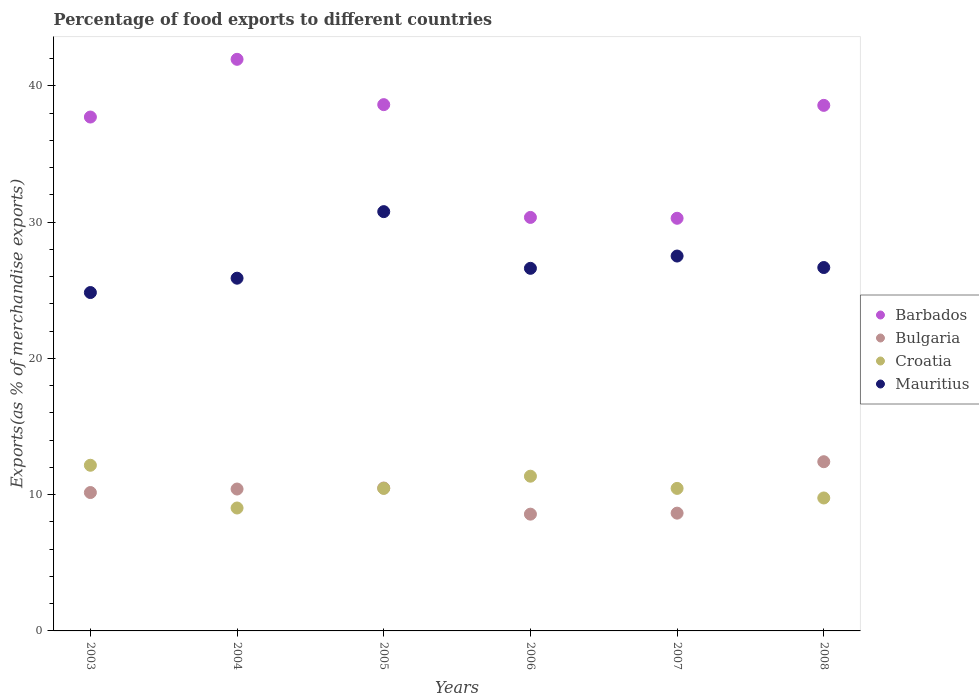How many different coloured dotlines are there?
Give a very brief answer. 4. Is the number of dotlines equal to the number of legend labels?
Provide a short and direct response. Yes. What is the percentage of exports to different countries in Croatia in 2007?
Give a very brief answer. 10.46. Across all years, what is the maximum percentage of exports to different countries in Croatia?
Offer a terse response. 12.16. Across all years, what is the minimum percentage of exports to different countries in Croatia?
Your answer should be compact. 9.02. What is the total percentage of exports to different countries in Mauritius in the graph?
Make the answer very short. 162.29. What is the difference between the percentage of exports to different countries in Mauritius in 2006 and that in 2007?
Provide a short and direct response. -0.9. What is the difference between the percentage of exports to different countries in Croatia in 2004 and the percentage of exports to different countries in Bulgaria in 2003?
Your response must be concise. -1.13. What is the average percentage of exports to different countries in Mauritius per year?
Keep it short and to the point. 27.05. In the year 2005, what is the difference between the percentage of exports to different countries in Mauritius and percentage of exports to different countries in Barbados?
Provide a short and direct response. -7.85. In how many years, is the percentage of exports to different countries in Croatia greater than 14 %?
Provide a short and direct response. 0. What is the ratio of the percentage of exports to different countries in Bulgaria in 2004 to that in 2007?
Keep it short and to the point. 1.2. Is the difference between the percentage of exports to different countries in Mauritius in 2003 and 2005 greater than the difference between the percentage of exports to different countries in Barbados in 2003 and 2005?
Provide a succinct answer. No. What is the difference between the highest and the second highest percentage of exports to different countries in Barbados?
Provide a succinct answer. 3.33. What is the difference between the highest and the lowest percentage of exports to different countries in Croatia?
Provide a succinct answer. 3.14. Is it the case that in every year, the sum of the percentage of exports to different countries in Barbados and percentage of exports to different countries in Croatia  is greater than the sum of percentage of exports to different countries in Bulgaria and percentage of exports to different countries in Mauritius?
Give a very brief answer. No. Is it the case that in every year, the sum of the percentage of exports to different countries in Croatia and percentage of exports to different countries in Mauritius  is greater than the percentage of exports to different countries in Bulgaria?
Your response must be concise. Yes. How many dotlines are there?
Your answer should be compact. 4. What is the difference between two consecutive major ticks on the Y-axis?
Ensure brevity in your answer.  10. Does the graph contain any zero values?
Ensure brevity in your answer.  No. Does the graph contain grids?
Keep it short and to the point. No. Where does the legend appear in the graph?
Your response must be concise. Center right. How are the legend labels stacked?
Ensure brevity in your answer.  Vertical. What is the title of the graph?
Make the answer very short. Percentage of food exports to different countries. Does "Albania" appear as one of the legend labels in the graph?
Offer a very short reply. No. What is the label or title of the Y-axis?
Give a very brief answer. Exports(as % of merchandise exports). What is the Exports(as % of merchandise exports) of Barbados in 2003?
Offer a very short reply. 37.71. What is the Exports(as % of merchandise exports) of Bulgaria in 2003?
Give a very brief answer. 10.16. What is the Exports(as % of merchandise exports) of Croatia in 2003?
Provide a short and direct response. 12.16. What is the Exports(as % of merchandise exports) in Mauritius in 2003?
Your answer should be very brief. 24.83. What is the Exports(as % of merchandise exports) of Barbados in 2004?
Make the answer very short. 41.95. What is the Exports(as % of merchandise exports) of Bulgaria in 2004?
Offer a terse response. 10.41. What is the Exports(as % of merchandise exports) of Croatia in 2004?
Your response must be concise. 9.02. What is the Exports(as % of merchandise exports) in Mauritius in 2004?
Provide a succinct answer. 25.89. What is the Exports(as % of merchandise exports) of Barbados in 2005?
Your answer should be very brief. 38.62. What is the Exports(as % of merchandise exports) in Bulgaria in 2005?
Offer a very short reply. 10.49. What is the Exports(as % of merchandise exports) in Croatia in 2005?
Provide a succinct answer. 10.46. What is the Exports(as % of merchandise exports) of Mauritius in 2005?
Your answer should be compact. 30.77. What is the Exports(as % of merchandise exports) in Barbados in 2006?
Your answer should be very brief. 30.35. What is the Exports(as % of merchandise exports) of Bulgaria in 2006?
Provide a short and direct response. 8.57. What is the Exports(as % of merchandise exports) in Croatia in 2006?
Provide a succinct answer. 11.36. What is the Exports(as % of merchandise exports) of Mauritius in 2006?
Keep it short and to the point. 26.61. What is the Exports(as % of merchandise exports) in Barbados in 2007?
Give a very brief answer. 30.28. What is the Exports(as % of merchandise exports) of Bulgaria in 2007?
Your answer should be compact. 8.64. What is the Exports(as % of merchandise exports) in Croatia in 2007?
Keep it short and to the point. 10.46. What is the Exports(as % of merchandise exports) in Mauritius in 2007?
Provide a succinct answer. 27.51. What is the Exports(as % of merchandise exports) of Barbados in 2008?
Offer a very short reply. 38.57. What is the Exports(as % of merchandise exports) of Bulgaria in 2008?
Ensure brevity in your answer.  12.42. What is the Exports(as % of merchandise exports) in Croatia in 2008?
Give a very brief answer. 9.76. What is the Exports(as % of merchandise exports) in Mauritius in 2008?
Offer a terse response. 26.67. Across all years, what is the maximum Exports(as % of merchandise exports) of Barbados?
Give a very brief answer. 41.95. Across all years, what is the maximum Exports(as % of merchandise exports) in Bulgaria?
Your answer should be compact. 12.42. Across all years, what is the maximum Exports(as % of merchandise exports) in Croatia?
Offer a very short reply. 12.16. Across all years, what is the maximum Exports(as % of merchandise exports) in Mauritius?
Ensure brevity in your answer.  30.77. Across all years, what is the minimum Exports(as % of merchandise exports) of Barbados?
Ensure brevity in your answer.  30.28. Across all years, what is the minimum Exports(as % of merchandise exports) of Bulgaria?
Provide a succinct answer. 8.57. Across all years, what is the minimum Exports(as % of merchandise exports) in Croatia?
Offer a terse response. 9.02. Across all years, what is the minimum Exports(as % of merchandise exports) in Mauritius?
Keep it short and to the point. 24.83. What is the total Exports(as % of merchandise exports) of Barbados in the graph?
Offer a terse response. 217.49. What is the total Exports(as % of merchandise exports) of Bulgaria in the graph?
Your answer should be very brief. 60.69. What is the total Exports(as % of merchandise exports) of Croatia in the graph?
Your answer should be very brief. 63.21. What is the total Exports(as % of merchandise exports) of Mauritius in the graph?
Give a very brief answer. 162.29. What is the difference between the Exports(as % of merchandise exports) of Barbados in 2003 and that in 2004?
Offer a terse response. -4.24. What is the difference between the Exports(as % of merchandise exports) of Bulgaria in 2003 and that in 2004?
Your answer should be compact. -0.26. What is the difference between the Exports(as % of merchandise exports) of Croatia in 2003 and that in 2004?
Your response must be concise. 3.14. What is the difference between the Exports(as % of merchandise exports) in Mauritius in 2003 and that in 2004?
Offer a terse response. -1.05. What is the difference between the Exports(as % of merchandise exports) in Barbados in 2003 and that in 2005?
Your answer should be very brief. -0.91. What is the difference between the Exports(as % of merchandise exports) in Bulgaria in 2003 and that in 2005?
Provide a short and direct response. -0.33. What is the difference between the Exports(as % of merchandise exports) of Croatia in 2003 and that in 2005?
Provide a short and direct response. 1.7. What is the difference between the Exports(as % of merchandise exports) of Mauritius in 2003 and that in 2005?
Provide a succinct answer. -5.94. What is the difference between the Exports(as % of merchandise exports) of Barbados in 2003 and that in 2006?
Provide a succinct answer. 7.37. What is the difference between the Exports(as % of merchandise exports) of Bulgaria in 2003 and that in 2006?
Provide a succinct answer. 1.59. What is the difference between the Exports(as % of merchandise exports) in Croatia in 2003 and that in 2006?
Offer a terse response. 0.8. What is the difference between the Exports(as % of merchandise exports) of Mauritius in 2003 and that in 2006?
Offer a very short reply. -1.78. What is the difference between the Exports(as % of merchandise exports) of Barbados in 2003 and that in 2007?
Your answer should be compact. 7.43. What is the difference between the Exports(as % of merchandise exports) of Bulgaria in 2003 and that in 2007?
Offer a terse response. 1.51. What is the difference between the Exports(as % of merchandise exports) of Croatia in 2003 and that in 2007?
Offer a very short reply. 1.7. What is the difference between the Exports(as % of merchandise exports) in Mauritius in 2003 and that in 2007?
Ensure brevity in your answer.  -2.68. What is the difference between the Exports(as % of merchandise exports) in Barbados in 2003 and that in 2008?
Ensure brevity in your answer.  -0.86. What is the difference between the Exports(as % of merchandise exports) in Bulgaria in 2003 and that in 2008?
Ensure brevity in your answer.  -2.26. What is the difference between the Exports(as % of merchandise exports) in Croatia in 2003 and that in 2008?
Your response must be concise. 2.4. What is the difference between the Exports(as % of merchandise exports) of Mauritius in 2003 and that in 2008?
Your answer should be very brief. -1.84. What is the difference between the Exports(as % of merchandise exports) in Barbados in 2004 and that in 2005?
Offer a very short reply. 3.33. What is the difference between the Exports(as % of merchandise exports) of Bulgaria in 2004 and that in 2005?
Keep it short and to the point. -0.07. What is the difference between the Exports(as % of merchandise exports) in Croatia in 2004 and that in 2005?
Offer a very short reply. -1.44. What is the difference between the Exports(as % of merchandise exports) in Mauritius in 2004 and that in 2005?
Make the answer very short. -4.88. What is the difference between the Exports(as % of merchandise exports) of Barbados in 2004 and that in 2006?
Your answer should be very brief. 11.6. What is the difference between the Exports(as % of merchandise exports) of Bulgaria in 2004 and that in 2006?
Ensure brevity in your answer.  1.84. What is the difference between the Exports(as % of merchandise exports) in Croatia in 2004 and that in 2006?
Your answer should be very brief. -2.33. What is the difference between the Exports(as % of merchandise exports) in Mauritius in 2004 and that in 2006?
Your answer should be compact. -0.72. What is the difference between the Exports(as % of merchandise exports) in Barbados in 2004 and that in 2007?
Ensure brevity in your answer.  11.67. What is the difference between the Exports(as % of merchandise exports) in Bulgaria in 2004 and that in 2007?
Offer a terse response. 1.77. What is the difference between the Exports(as % of merchandise exports) in Croatia in 2004 and that in 2007?
Your response must be concise. -1.44. What is the difference between the Exports(as % of merchandise exports) in Mauritius in 2004 and that in 2007?
Make the answer very short. -1.63. What is the difference between the Exports(as % of merchandise exports) in Barbados in 2004 and that in 2008?
Offer a very short reply. 3.38. What is the difference between the Exports(as % of merchandise exports) of Bulgaria in 2004 and that in 2008?
Offer a terse response. -2. What is the difference between the Exports(as % of merchandise exports) in Croatia in 2004 and that in 2008?
Keep it short and to the point. -0.74. What is the difference between the Exports(as % of merchandise exports) of Mauritius in 2004 and that in 2008?
Provide a short and direct response. -0.78. What is the difference between the Exports(as % of merchandise exports) in Barbados in 2005 and that in 2006?
Make the answer very short. 8.28. What is the difference between the Exports(as % of merchandise exports) of Bulgaria in 2005 and that in 2006?
Your answer should be compact. 1.92. What is the difference between the Exports(as % of merchandise exports) in Croatia in 2005 and that in 2006?
Provide a succinct answer. -0.9. What is the difference between the Exports(as % of merchandise exports) in Mauritius in 2005 and that in 2006?
Your response must be concise. 4.16. What is the difference between the Exports(as % of merchandise exports) in Barbados in 2005 and that in 2007?
Provide a short and direct response. 8.34. What is the difference between the Exports(as % of merchandise exports) in Bulgaria in 2005 and that in 2007?
Provide a short and direct response. 1.84. What is the difference between the Exports(as % of merchandise exports) of Mauritius in 2005 and that in 2007?
Your answer should be very brief. 3.26. What is the difference between the Exports(as % of merchandise exports) of Barbados in 2005 and that in 2008?
Your answer should be compact. 0.05. What is the difference between the Exports(as % of merchandise exports) in Bulgaria in 2005 and that in 2008?
Ensure brevity in your answer.  -1.93. What is the difference between the Exports(as % of merchandise exports) in Croatia in 2005 and that in 2008?
Keep it short and to the point. 0.7. What is the difference between the Exports(as % of merchandise exports) of Mauritius in 2005 and that in 2008?
Your answer should be very brief. 4.1. What is the difference between the Exports(as % of merchandise exports) of Barbados in 2006 and that in 2007?
Offer a terse response. 0.06. What is the difference between the Exports(as % of merchandise exports) in Bulgaria in 2006 and that in 2007?
Keep it short and to the point. -0.07. What is the difference between the Exports(as % of merchandise exports) of Croatia in 2006 and that in 2007?
Your answer should be very brief. 0.9. What is the difference between the Exports(as % of merchandise exports) in Mauritius in 2006 and that in 2007?
Your response must be concise. -0.9. What is the difference between the Exports(as % of merchandise exports) in Barbados in 2006 and that in 2008?
Ensure brevity in your answer.  -8.22. What is the difference between the Exports(as % of merchandise exports) of Bulgaria in 2006 and that in 2008?
Your answer should be very brief. -3.85. What is the difference between the Exports(as % of merchandise exports) of Croatia in 2006 and that in 2008?
Your answer should be very brief. 1.6. What is the difference between the Exports(as % of merchandise exports) of Mauritius in 2006 and that in 2008?
Offer a very short reply. -0.06. What is the difference between the Exports(as % of merchandise exports) in Barbados in 2007 and that in 2008?
Offer a terse response. -8.29. What is the difference between the Exports(as % of merchandise exports) of Bulgaria in 2007 and that in 2008?
Offer a terse response. -3.77. What is the difference between the Exports(as % of merchandise exports) of Croatia in 2007 and that in 2008?
Provide a short and direct response. 0.7. What is the difference between the Exports(as % of merchandise exports) in Mauritius in 2007 and that in 2008?
Provide a short and direct response. 0.84. What is the difference between the Exports(as % of merchandise exports) in Barbados in 2003 and the Exports(as % of merchandise exports) in Bulgaria in 2004?
Your answer should be compact. 27.3. What is the difference between the Exports(as % of merchandise exports) of Barbados in 2003 and the Exports(as % of merchandise exports) of Croatia in 2004?
Offer a very short reply. 28.69. What is the difference between the Exports(as % of merchandise exports) in Barbados in 2003 and the Exports(as % of merchandise exports) in Mauritius in 2004?
Give a very brief answer. 11.83. What is the difference between the Exports(as % of merchandise exports) in Bulgaria in 2003 and the Exports(as % of merchandise exports) in Croatia in 2004?
Offer a terse response. 1.14. What is the difference between the Exports(as % of merchandise exports) in Bulgaria in 2003 and the Exports(as % of merchandise exports) in Mauritius in 2004?
Provide a short and direct response. -15.73. What is the difference between the Exports(as % of merchandise exports) in Croatia in 2003 and the Exports(as % of merchandise exports) in Mauritius in 2004?
Offer a terse response. -13.73. What is the difference between the Exports(as % of merchandise exports) in Barbados in 2003 and the Exports(as % of merchandise exports) in Bulgaria in 2005?
Your answer should be compact. 27.23. What is the difference between the Exports(as % of merchandise exports) in Barbados in 2003 and the Exports(as % of merchandise exports) in Croatia in 2005?
Offer a terse response. 27.25. What is the difference between the Exports(as % of merchandise exports) of Barbados in 2003 and the Exports(as % of merchandise exports) of Mauritius in 2005?
Make the answer very short. 6.94. What is the difference between the Exports(as % of merchandise exports) of Bulgaria in 2003 and the Exports(as % of merchandise exports) of Croatia in 2005?
Your answer should be compact. -0.3. What is the difference between the Exports(as % of merchandise exports) of Bulgaria in 2003 and the Exports(as % of merchandise exports) of Mauritius in 2005?
Provide a short and direct response. -20.62. What is the difference between the Exports(as % of merchandise exports) in Croatia in 2003 and the Exports(as % of merchandise exports) in Mauritius in 2005?
Your response must be concise. -18.61. What is the difference between the Exports(as % of merchandise exports) in Barbados in 2003 and the Exports(as % of merchandise exports) in Bulgaria in 2006?
Your response must be concise. 29.14. What is the difference between the Exports(as % of merchandise exports) of Barbados in 2003 and the Exports(as % of merchandise exports) of Croatia in 2006?
Ensure brevity in your answer.  26.36. What is the difference between the Exports(as % of merchandise exports) in Barbados in 2003 and the Exports(as % of merchandise exports) in Mauritius in 2006?
Offer a terse response. 11.1. What is the difference between the Exports(as % of merchandise exports) of Bulgaria in 2003 and the Exports(as % of merchandise exports) of Croatia in 2006?
Your answer should be very brief. -1.2. What is the difference between the Exports(as % of merchandise exports) in Bulgaria in 2003 and the Exports(as % of merchandise exports) in Mauritius in 2006?
Offer a terse response. -16.45. What is the difference between the Exports(as % of merchandise exports) in Croatia in 2003 and the Exports(as % of merchandise exports) in Mauritius in 2006?
Your answer should be compact. -14.45. What is the difference between the Exports(as % of merchandise exports) of Barbados in 2003 and the Exports(as % of merchandise exports) of Bulgaria in 2007?
Provide a short and direct response. 29.07. What is the difference between the Exports(as % of merchandise exports) in Barbados in 2003 and the Exports(as % of merchandise exports) in Croatia in 2007?
Offer a terse response. 27.25. What is the difference between the Exports(as % of merchandise exports) in Barbados in 2003 and the Exports(as % of merchandise exports) in Mauritius in 2007?
Provide a succinct answer. 10.2. What is the difference between the Exports(as % of merchandise exports) of Bulgaria in 2003 and the Exports(as % of merchandise exports) of Croatia in 2007?
Offer a very short reply. -0.3. What is the difference between the Exports(as % of merchandise exports) in Bulgaria in 2003 and the Exports(as % of merchandise exports) in Mauritius in 2007?
Give a very brief answer. -17.36. What is the difference between the Exports(as % of merchandise exports) in Croatia in 2003 and the Exports(as % of merchandise exports) in Mauritius in 2007?
Your answer should be compact. -15.35. What is the difference between the Exports(as % of merchandise exports) of Barbados in 2003 and the Exports(as % of merchandise exports) of Bulgaria in 2008?
Your response must be concise. 25.3. What is the difference between the Exports(as % of merchandise exports) in Barbados in 2003 and the Exports(as % of merchandise exports) in Croatia in 2008?
Your response must be concise. 27.96. What is the difference between the Exports(as % of merchandise exports) in Barbados in 2003 and the Exports(as % of merchandise exports) in Mauritius in 2008?
Provide a succinct answer. 11.04. What is the difference between the Exports(as % of merchandise exports) in Bulgaria in 2003 and the Exports(as % of merchandise exports) in Croatia in 2008?
Offer a terse response. 0.4. What is the difference between the Exports(as % of merchandise exports) in Bulgaria in 2003 and the Exports(as % of merchandise exports) in Mauritius in 2008?
Your answer should be compact. -16.51. What is the difference between the Exports(as % of merchandise exports) of Croatia in 2003 and the Exports(as % of merchandise exports) of Mauritius in 2008?
Give a very brief answer. -14.51. What is the difference between the Exports(as % of merchandise exports) of Barbados in 2004 and the Exports(as % of merchandise exports) of Bulgaria in 2005?
Keep it short and to the point. 31.46. What is the difference between the Exports(as % of merchandise exports) of Barbados in 2004 and the Exports(as % of merchandise exports) of Croatia in 2005?
Give a very brief answer. 31.49. What is the difference between the Exports(as % of merchandise exports) in Barbados in 2004 and the Exports(as % of merchandise exports) in Mauritius in 2005?
Offer a terse response. 11.18. What is the difference between the Exports(as % of merchandise exports) of Bulgaria in 2004 and the Exports(as % of merchandise exports) of Croatia in 2005?
Your answer should be very brief. -0.05. What is the difference between the Exports(as % of merchandise exports) in Bulgaria in 2004 and the Exports(as % of merchandise exports) in Mauritius in 2005?
Your answer should be compact. -20.36. What is the difference between the Exports(as % of merchandise exports) of Croatia in 2004 and the Exports(as % of merchandise exports) of Mauritius in 2005?
Your response must be concise. -21.75. What is the difference between the Exports(as % of merchandise exports) in Barbados in 2004 and the Exports(as % of merchandise exports) in Bulgaria in 2006?
Give a very brief answer. 33.38. What is the difference between the Exports(as % of merchandise exports) of Barbados in 2004 and the Exports(as % of merchandise exports) of Croatia in 2006?
Your answer should be compact. 30.6. What is the difference between the Exports(as % of merchandise exports) of Barbados in 2004 and the Exports(as % of merchandise exports) of Mauritius in 2006?
Provide a succinct answer. 15.34. What is the difference between the Exports(as % of merchandise exports) of Bulgaria in 2004 and the Exports(as % of merchandise exports) of Croatia in 2006?
Offer a very short reply. -0.94. What is the difference between the Exports(as % of merchandise exports) of Bulgaria in 2004 and the Exports(as % of merchandise exports) of Mauritius in 2006?
Keep it short and to the point. -16.2. What is the difference between the Exports(as % of merchandise exports) in Croatia in 2004 and the Exports(as % of merchandise exports) in Mauritius in 2006?
Offer a very short reply. -17.59. What is the difference between the Exports(as % of merchandise exports) of Barbados in 2004 and the Exports(as % of merchandise exports) of Bulgaria in 2007?
Provide a short and direct response. 33.31. What is the difference between the Exports(as % of merchandise exports) of Barbados in 2004 and the Exports(as % of merchandise exports) of Croatia in 2007?
Make the answer very short. 31.49. What is the difference between the Exports(as % of merchandise exports) in Barbados in 2004 and the Exports(as % of merchandise exports) in Mauritius in 2007?
Make the answer very short. 14.44. What is the difference between the Exports(as % of merchandise exports) of Bulgaria in 2004 and the Exports(as % of merchandise exports) of Croatia in 2007?
Give a very brief answer. -0.05. What is the difference between the Exports(as % of merchandise exports) in Bulgaria in 2004 and the Exports(as % of merchandise exports) in Mauritius in 2007?
Make the answer very short. -17.1. What is the difference between the Exports(as % of merchandise exports) of Croatia in 2004 and the Exports(as % of merchandise exports) of Mauritius in 2007?
Keep it short and to the point. -18.49. What is the difference between the Exports(as % of merchandise exports) in Barbados in 2004 and the Exports(as % of merchandise exports) in Bulgaria in 2008?
Your response must be concise. 29.53. What is the difference between the Exports(as % of merchandise exports) of Barbados in 2004 and the Exports(as % of merchandise exports) of Croatia in 2008?
Provide a short and direct response. 32.19. What is the difference between the Exports(as % of merchandise exports) in Barbados in 2004 and the Exports(as % of merchandise exports) in Mauritius in 2008?
Your response must be concise. 15.28. What is the difference between the Exports(as % of merchandise exports) of Bulgaria in 2004 and the Exports(as % of merchandise exports) of Croatia in 2008?
Offer a terse response. 0.66. What is the difference between the Exports(as % of merchandise exports) in Bulgaria in 2004 and the Exports(as % of merchandise exports) in Mauritius in 2008?
Provide a short and direct response. -16.26. What is the difference between the Exports(as % of merchandise exports) of Croatia in 2004 and the Exports(as % of merchandise exports) of Mauritius in 2008?
Provide a succinct answer. -17.65. What is the difference between the Exports(as % of merchandise exports) of Barbados in 2005 and the Exports(as % of merchandise exports) of Bulgaria in 2006?
Your answer should be very brief. 30.05. What is the difference between the Exports(as % of merchandise exports) in Barbados in 2005 and the Exports(as % of merchandise exports) in Croatia in 2006?
Offer a terse response. 27.27. What is the difference between the Exports(as % of merchandise exports) of Barbados in 2005 and the Exports(as % of merchandise exports) of Mauritius in 2006?
Offer a very short reply. 12.01. What is the difference between the Exports(as % of merchandise exports) in Bulgaria in 2005 and the Exports(as % of merchandise exports) in Croatia in 2006?
Offer a terse response. -0.87. What is the difference between the Exports(as % of merchandise exports) of Bulgaria in 2005 and the Exports(as % of merchandise exports) of Mauritius in 2006?
Provide a short and direct response. -16.12. What is the difference between the Exports(as % of merchandise exports) in Croatia in 2005 and the Exports(as % of merchandise exports) in Mauritius in 2006?
Provide a short and direct response. -16.15. What is the difference between the Exports(as % of merchandise exports) in Barbados in 2005 and the Exports(as % of merchandise exports) in Bulgaria in 2007?
Give a very brief answer. 29.98. What is the difference between the Exports(as % of merchandise exports) of Barbados in 2005 and the Exports(as % of merchandise exports) of Croatia in 2007?
Offer a very short reply. 28.16. What is the difference between the Exports(as % of merchandise exports) of Barbados in 2005 and the Exports(as % of merchandise exports) of Mauritius in 2007?
Make the answer very short. 11.11. What is the difference between the Exports(as % of merchandise exports) in Bulgaria in 2005 and the Exports(as % of merchandise exports) in Croatia in 2007?
Keep it short and to the point. 0.03. What is the difference between the Exports(as % of merchandise exports) of Bulgaria in 2005 and the Exports(as % of merchandise exports) of Mauritius in 2007?
Offer a very short reply. -17.03. What is the difference between the Exports(as % of merchandise exports) in Croatia in 2005 and the Exports(as % of merchandise exports) in Mauritius in 2007?
Give a very brief answer. -17.05. What is the difference between the Exports(as % of merchandise exports) of Barbados in 2005 and the Exports(as % of merchandise exports) of Bulgaria in 2008?
Your answer should be compact. 26.21. What is the difference between the Exports(as % of merchandise exports) of Barbados in 2005 and the Exports(as % of merchandise exports) of Croatia in 2008?
Ensure brevity in your answer.  28.87. What is the difference between the Exports(as % of merchandise exports) in Barbados in 2005 and the Exports(as % of merchandise exports) in Mauritius in 2008?
Ensure brevity in your answer.  11.95. What is the difference between the Exports(as % of merchandise exports) in Bulgaria in 2005 and the Exports(as % of merchandise exports) in Croatia in 2008?
Give a very brief answer. 0.73. What is the difference between the Exports(as % of merchandise exports) of Bulgaria in 2005 and the Exports(as % of merchandise exports) of Mauritius in 2008?
Your answer should be compact. -16.18. What is the difference between the Exports(as % of merchandise exports) of Croatia in 2005 and the Exports(as % of merchandise exports) of Mauritius in 2008?
Offer a terse response. -16.21. What is the difference between the Exports(as % of merchandise exports) of Barbados in 2006 and the Exports(as % of merchandise exports) of Bulgaria in 2007?
Provide a short and direct response. 21.7. What is the difference between the Exports(as % of merchandise exports) in Barbados in 2006 and the Exports(as % of merchandise exports) in Croatia in 2007?
Ensure brevity in your answer.  19.89. What is the difference between the Exports(as % of merchandise exports) in Barbados in 2006 and the Exports(as % of merchandise exports) in Mauritius in 2007?
Your response must be concise. 2.83. What is the difference between the Exports(as % of merchandise exports) of Bulgaria in 2006 and the Exports(as % of merchandise exports) of Croatia in 2007?
Keep it short and to the point. -1.89. What is the difference between the Exports(as % of merchandise exports) of Bulgaria in 2006 and the Exports(as % of merchandise exports) of Mauritius in 2007?
Keep it short and to the point. -18.94. What is the difference between the Exports(as % of merchandise exports) of Croatia in 2006 and the Exports(as % of merchandise exports) of Mauritius in 2007?
Provide a short and direct response. -16.16. What is the difference between the Exports(as % of merchandise exports) of Barbados in 2006 and the Exports(as % of merchandise exports) of Bulgaria in 2008?
Provide a short and direct response. 17.93. What is the difference between the Exports(as % of merchandise exports) in Barbados in 2006 and the Exports(as % of merchandise exports) in Croatia in 2008?
Give a very brief answer. 20.59. What is the difference between the Exports(as % of merchandise exports) of Barbados in 2006 and the Exports(as % of merchandise exports) of Mauritius in 2008?
Keep it short and to the point. 3.68. What is the difference between the Exports(as % of merchandise exports) in Bulgaria in 2006 and the Exports(as % of merchandise exports) in Croatia in 2008?
Your answer should be compact. -1.19. What is the difference between the Exports(as % of merchandise exports) in Bulgaria in 2006 and the Exports(as % of merchandise exports) in Mauritius in 2008?
Provide a succinct answer. -18.1. What is the difference between the Exports(as % of merchandise exports) in Croatia in 2006 and the Exports(as % of merchandise exports) in Mauritius in 2008?
Provide a succinct answer. -15.31. What is the difference between the Exports(as % of merchandise exports) of Barbados in 2007 and the Exports(as % of merchandise exports) of Bulgaria in 2008?
Ensure brevity in your answer.  17.87. What is the difference between the Exports(as % of merchandise exports) in Barbados in 2007 and the Exports(as % of merchandise exports) in Croatia in 2008?
Provide a short and direct response. 20.53. What is the difference between the Exports(as % of merchandise exports) in Barbados in 2007 and the Exports(as % of merchandise exports) in Mauritius in 2008?
Make the answer very short. 3.61. What is the difference between the Exports(as % of merchandise exports) in Bulgaria in 2007 and the Exports(as % of merchandise exports) in Croatia in 2008?
Give a very brief answer. -1.11. What is the difference between the Exports(as % of merchandise exports) in Bulgaria in 2007 and the Exports(as % of merchandise exports) in Mauritius in 2008?
Keep it short and to the point. -18.03. What is the difference between the Exports(as % of merchandise exports) in Croatia in 2007 and the Exports(as % of merchandise exports) in Mauritius in 2008?
Provide a short and direct response. -16.21. What is the average Exports(as % of merchandise exports) of Barbados per year?
Provide a short and direct response. 36.25. What is the average Exports(as % of merchandise exports) of Bulgaria per year?
Give a very brief answer. 10.11. What is the average Exports(as % of merchandise exports) of Croatia per year?
Provide a succinct answer. 10.54. What is the average Exports(as % of merchandise exports) in Mauritius per year?
Keep it short and to the point. 27.05. In the year 2003, what is the difference between the Exports(as % of merchandise exports) of Barbados and Exports(as % of merchandise exports) of Bulgaria?
Make the answer very short. 27.56. In the year 2003, what is the difference between the Exports(as % of merchandise exports) of Barbados and Exports(as % of merchandise exports) of Croatia?
Make the answer very short. 25.56. In the year 2003, what is the difference between the Exports(as % of merchandise exports) of Barbados and Exports(as % of merchandise exports) of Mauritius?
Your answer should be very brief. 12.88. In the year 2003, what is the difference between the Exports(as % of merchandise exports) of Bulgaria and Exports(as % of merchandise exports) of Croatia?
Give a very brief answer. -2. In the year 2003, what is the difference between the Exports(as % of merchandise exports) of Bulgaria and Exports(as % of merchandise exports) of Mauritius?
Your response must be concise. -14.68. In the year 2003, what is the difference between the Exports(as % of merchandise exports) in Croatia and Exports(as % of merchandise exports) in Mauritius?
Offer a very short reply. -12.68. In the year 2004, what is the difference between the Exports(as % of merchandise exports) of Barbados and Exports(as % of merchandise exports) of Bulgaria?
Keep it short and to the point. 31.54. In the year 2004, what is the difference between the Exports(as % of merchandise exports) of Barbados and Exports(as % of merchandise exports) of Croatia?
Provide a short and direct response. 32.93. In the year 2004, what is the difference between the Exports(as % of merchandise exports) of Barbados and Exports(as % of merchandise exports) of Mauritius?
Offer a very short reply. 16.06. In the year 2004, what is the difference between the Exports(as % of merchandise exports) of Bulgaria and Exports(as % of merchandise exports) of Croatia?
Ensure brevity in your answer.  1.39. In the year 2004, what is the difference between the Exports(as % of merchandise exports) in Bulgaria and Exports(as % of merchandise exports) in Mauritius?
Ensure brevity in your answer.  -15.47. In the year 2004, what is the difference between the Exports(as % of merchandise exports) of Croatia and Exports(as % of merchandise exports) of Mauritius?
Keep it short and to the point. -16.87. In the year 2005, what is the difference between the Exports(as % of merchandise exports) of Barbados and Exports(as % of merchandise exports) of Bulgaria?
Offer a terse response. 28.14. In the year 2005, what is the difference between the Exports(as % of merchandise exports) in Barbados and Exports(as % of merchandise exports) in Croatia?
Offer a terse response. 28.16. In the year 2005, what is the difference between the Exports(as % of merchandise exports) in Barbados and Exports(as % of merchandise exports) in Mauritius?
Give a very brief answer. 7.85. In the year 2005, what is the difference between the Exports(as % of merchandise exports) of Bulgaria and Exports(as % of merchandise exports) of Croatia?
Make the answer very short. 0.03. In the year 2005, what is the difference between the Exports(as % of merchandise exports) of Bulgaria and Exports(as % of merchandise exports) of Mauritius?
Your answer should be very brief. -20.28. In the year 2005, what is the difference between the Exports(as % of merchandise exports) in Croatia and Exports(as % of merchandise exports) in Mauritius?
Your response must be concise. -20.31. In the year 2006, what is the difference between the Exports(as % of merchandise exports) of Barbados and Exports(as % of merchandise exports) of Bulgaria?
Offer a terse response. 21.78. In the year 2006, what is the difference between the Exports(as % of merchandise exports) in Barbados and Exports(as % of merchandise exports) in Croatia?
Keep it short and to the point. 18.99. In the year 2006, what is the difference between the Exports(as % of merchandise exports) of Barbados and Exports(as % of merchandise exports) of Mauritius?
Provide a short and direct response. 3.74. In the year 2006, what is the difference between the Exports(as % of merchandise exports) of Bulgaria and Exports(as % of merchandise exports) of Croatia?
Your answer should be very brief. -2.79. In the year 2006, what is the difference between the Exports(as % of merchandise exports) of Bulgaria and Exports(as % of merchandise exports) of Mauritius?
Your answer should be very brief. -18.04. In the year 2006, what is the difference between the Exports(as % of merchandise exports) of Croatia and Exports(as % of merchandise exports) of Mauritius?
Give a very brief answer. -15.26. In the year 2007, what is the difference between the Exports(as % of merchandise exports) in Barbados and Exports(as % of merchandise exports) in Bulgaria?
Give a very brief answer. 21.64. In the year 2007, what is the difference between the Exports(as % of merchandise exports) in Barbados and Exports(as % of merchandise exports) in Croatia?
Provide a short and direct response. 19.82. In the year 2007, what is the difference between the Exports(as % of merchandise exports) in Barbados and Exports(as % of merchandise exports) in Mauritius?
Your answer should be very brief. 2.77. In the year 2007, what is the difference between the Exports(as % of merchandise exports) of Bulgaria and Exports(as % of merchandise exports) of Croatia?
Keep it short and to the point. -1.82. In the year 2007, what is the difference between the Exports(as % of merchandise exports) of Bulgaria and Exports(as % of merchandise exports) of Mauritius?
Keep it short and to the point. -18.87. In the year 2007, what is the difference between the Exports(as % of merchandise exports) of Croatia and Exports(as % of merchandise exports) of Mauritius?
Offer a very short reply. -17.05. In the year 2008, what is the difference between the Exports(as % of merchandise exports) in Barbados and Exports(as % of merchandise exports) in Bulgaria?
Give a very brief answer. 26.15. In the year 2008, what is the difference between the Exports(as % of merchandise exports) of Barbados and Exports(as % of merchandise exports) of Croatia?
Your response must be concise. 28.81. In the year 2008, what is the difference between the Exports(as % of merchandise exports) in Barbados and Exports(as % of merchandise exports) in Mauritius?
Your answer should be compact. 11.9. In the year 2008, what is the difference between the Exports(as % of merchandise exports) of Bulgaria and Exports(as % of merchandise exports) of Croatia?
Make the answer very short. 2.66. In the year 2008, what is the difference between the Exports(as % of merchandise exports) of Bulgaria and Exports(as % of merchandise exports) of Mauritius?
Your answer should be compact. -14.25. In the year 2008, what is the difference between the Exports(as % of merchandise exports) of Croatia and Exports(as % of merchandise exports) of Mauritius?
Your answer should be compact. -16.91. What is the ratio of the Exports(as % of merchandise exports) in Barbados in 2003 to that in 2004?
Give a very brief answer. 0.9. What is the ratio of the Exports(as % of merchandise exports) of Bulgaria in 2003 to that in 2004?
Make the answer very short. 0.98. What is the ratio of the Exports(as % of merchandise exports) of Croatia in 2003 to that in 2004?
Provide a succinct answer. 1.35. What is the ratio of the Exports(as % of merchandise exports) in Mauritius in 2003 to that in 2004?
Provide a succinct answer. 0.96. What is the ratio of the Exports(as % of merchandise exports) in Barbados in 2003 to that in 2005?
Make the answer very short. 0.98. What is the ratio of the Exports(as % of merchandise exports) of Bulgaria in 2003 to that in 2005?
Your answer should be compact. 0.97. What is the ratio of the Exports(as % of merchandise exports) of Croatia in 2003 to that in 2005?
Offer a terse response. 1.16. What is the ratio of the Exports(as % of merchandise exports) in Mauritius in 2003 to that in 2005?
Your answer should be very brief. 0.81. What is the ratio of the Exports(as % of merchandise exports) in Barbados in 2003 to that in 2006?
Make the answer very short. 1.24. What is the ratio of the Exports(as % of merchandise exports) in Bulgaria in 2003 to that in 2006?
Ensure brevity in your answer.  1.19. What is the ratio of the Exports(as % of merchandise exports) of Croatia in 2003 to that in 2006?
Offer a very short reply. 1.07. What is the ratio of the Exports(as % of merchandise exports) in Mauritius in 2003 to that in 2006?
Your answer should be very brief. 0.93. What is the ratio of the Exports(as % of merchandise exports) in Barbados in 2003 to that in 2007?
Make the answer very short. 1.25. What is the ratio of the Exports(as % of merchandise exports) of Bulgaria in 2003 to that in 2007?
Ensure brevity in your answer.  1.17. What is the ratio of the Exports(as % of merchandise exports) in Croatia in 2003 to that in 2007?
Ensure brevity in your answer.  1.16. What is the ratio of the Exports(as % of merchandise exports) in Mauritius in 2003 to that in 2007?
Your answer should be very brief. 0.9. What is the ratio of the Exports(as % of merchandise exports) of Barbados in 2003 to that in 2008?
Your answer should be very brief. 0.98. What is the ratio of the Exports(as % of merchandise exports) in Bulgaria in 2003 to that in 2008?
Give a very brief answer. 0.82. What is the ratio of the Exports(as % of merchandise exports) of Croatia in 2003 to that in 2008?
Offer a terse response. 1.25. What is the ratio of the Exports(as % of merchandise exports) of Mauritius in 2003 to that in 2008?
Offer a very short reply. 0.93. What is the ratio of the Exports(as % of merchandise exports) in Barbados in 2004 to that in 2005?
Keep it short and to the point. 1.09. What is the ratio of the Exports(as % of merchandise exports) of Bulgaria in 2004 to that in 2005?
Your answer should be compact. 0.99. What is the ratio of the Exports(as % of merchandise exports) of Croatia in 2004 to that in 2005?
Keep it short and to the point. 0.86. What is the ratio of the Exports(as % of merchandise exports) of Mauritius in 2004 to that in 2005?
Ensure brevity in your answer.  0.84. What is the ratio of the Exports(as % of merchandise exports) in Barbados in 2004 to that in 2006?
Ensure brevity in your answer.  1.38. What is the ratio of the Exports(as % of merchandise exports) of Bulgaria in 2004 to that in 2006?
Give a very brief answer. 1.22. What is the ratio of the Exports(as % of merchandise exports) of Croatia in 2004 to that in 2006?
Your answer should be compact. 0.79. What is the ratio of the Exports(as % of merchandise exports) of Mauritius in 2004 to that in 2006?
Make the answer very short. 0.97. What is the ratio of the Exports(as % of merchandise exports) of Barbados in 2004 to that in 2007?
Your response must be concise. 1.39. What is the ratio of the Exports(as % of merchandise exports) of Bulgaria in 2004 to that in 2007?
Your answer should be very brief. 1.2. What is the ratio of the Exports(as % of merchandise exports) in Croatia in 2004 to that in 2007?
Provide a succinct answer. 0.86. What is the ratio of the Exports(as % of merchandise exports) of Mauritius in 2004 to that in 2007?
Offer a terse response. 0.94. What is the ratio of the Exports(as % of merchandise exports) in Barbados in 2004 to that in 2008?
Your response must be concise. 1.09. What is the ratio of the Exports(as % of merchandise exports) in Bulgaria in 2004 to that in 2008?
Provide a succinct answer. 0.84. What is the ratio of the Exports(as % of merchandise exports) in Croatia in 2004 to that in 2008?
Your answer should be very brief. 0.92. What is the ratio of the Exports(as % of merchandise exports) in Mauritius in 2004 to that in 2008?
Give a very brief answer. 0.97. What is the ratio of the Exports(as % of merchandise exports) in Barbados in 2005 to that in 2006?
Offer a very short reply. 1.27. What is the ratio of the Exports(as % of merchandise exports) of Bulgaria in 2005 to that in 2006?
Offer a terse response. 1.22. What is the ratio of the Exports(as % of merchandise exports) of Croatia in 2005 to that in 2006?
Make the answer very short. 0.92. What is the ratio of the Exports(as % of merchandise exports) of Mauritius in 2005 to that in 2006?
Your response must be concise. 1.16. What is the ratio of the Exports(as % of merchandise exports) in Barbados in 2005 to that in 2007?
Ensure brevity in your answer.  1.28. What is the ratio of the Exports(as % of merchandise exports) of Bulgaria in 2005 to that in 2007?
Provide a short and direct response. 1.21. What is the ratio of the Exports(as % of merchandise exports) of Croatia in 2005 to that in 2007?
Your response must be concise. 1. What is the ratio of the Exports(as % of merchandise exports) of Mauritius in 2005 to that in 2007?
Offer a terse response. 1.12. What is the ratio of the Exports(as % of merchandise exports) in Barbados in 2005 to that in 2008?
Offer a terse response. 1. What is the ratio of the Exports(as % of merchandise exports) of Bulgaria in 2005 to that in 2008?
Offer a terse response. 0.84. What is the ratio of the Exports(as % of merchandise exports) in Croatia in 2005 to that in 2008?
Provide a short and direct response. 1.07. What is the ratio of the Exports(as % of merchandise exports) of Mauritius in 2005 to that in 2008?
Your response must be concise. 1.15. What is the ratio of the Exports(as % of merchandise exports) in Barbados in 2006 to that in 2007?
Ensure brevity in your answer.  1. What is the ratio of the Exports(as % of merchandise exports) in Bulgaria in 2006 to that in 2007?
Offer a terse response. 0.99. What is the ratio of the Exports(as % of merchandise exports) of Croatia in 2006 to that in 2007?
Give a very brief answer. 1.09. What is the ratio of the Exports(as % of merchandise exports) of Mauritius in 2006 to that in 2007?
Your answer should be compact. 0.97. What is the ratio of the Exports(as % of merchandise exports) of Barbados in 2006 to that in 2008?
Offer a very short reply. 0.79. What is the ratio of the Exports(as % of merchandise exports) in Bulgaria in 2006 to that in 2008?
Keep it short and to the point. 0.69. What is the ratio of the Exports(as % of merchandise exports) of Croatia in 2006 to that in 2008?
Your answer should be very brief. 1.16. What is the ratio of the Exports(as % of merchandise exports) in Mauritius in 2006 to that in 2008?
Give a very brief answer. 1. What is the ratio of the Exports(as % of merchandise exports) in Barbados in 2007 to that in 2008?
Your response must be concise. 0.79. What is the ratio of the Exports(as % of merchandise exports) of Bulgaria in 2007 to that in 2008?
Make the answer very short. 0.7. What is the ratio of the Exports(as % of merchandise exports) in Croatia in 2007 to that in 2008?
Ensure brevity in your answer.  1.07. What is the ratio of the Exports(as % of merchandise exports) of Mauritius in 2007 to that in 2008?
Offer a terse response. 1.03. What is the difference between the highest and the second highest Exports(as % of merchandise exports) in Barbados?
Give a very brief answer. 3.33. What is the difference between the highest and the second highest Exports(as % of merchandise exports) of Bulgaria?
Your response must be concise. 1.93. What is the difference between the highest and the second highest Exports(as % of merchandise exports) in Croatia?
Give a very brief answer. 0.8. What is the difference between the highest and the second highest Exports(as % of merchandise exports) of Mauritius?
Offer a very short reply. 3.26. What is the difference between the highest and the lowest Exports(as % of merchandise exports) in Barbados?
Make the answer very short. 11.67. What is the difference between the highest and the lowest Exports(as % of merchandise exports) of Bulgaria?
Give a very brief answer. 3.85. What is the difference between the highest and the lowest Exports(as % of merchandise exports) in Croatia?
Your answer should be compact. 3.14. What is the difference between the highest and the lowest Exports(as % of merchandise exports) in Mauritius?
Give a very brief answer. 5.94. 